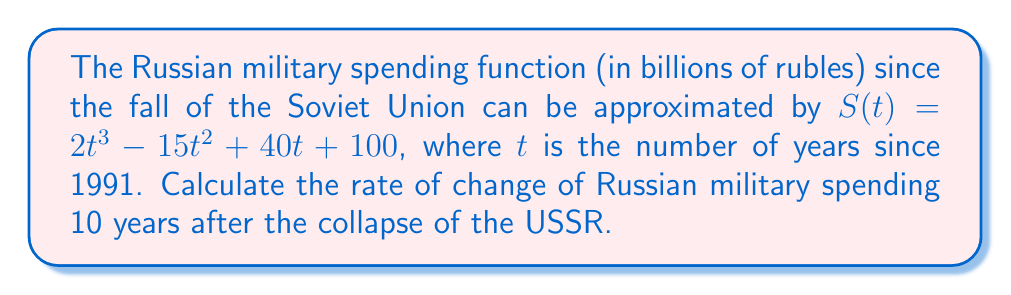Solve this math problem. To find the rate of change of Russian military spending, we need to calculate the derivative of the given function and evaluate it at $t = 10$.

Step 1: Calculate the derivative of $S(t)$.
$$S'(t) = \frac{d}{dt}(2t^3 - 15t^2 + 40t + 100)$$
$$S'(t) = 6t^2 - 30t + 40$$

Step 2: Evaluate $S'(t)$ at $t = 10$.
$$S'(10) = 6(10)^2 - 30(10) + 40$$
$$S'(10) = 600 - 300 + 40$$
$$S'(10) = 340$$

The rate of change of Russian military spending 10 years after the collapse of the Soviet Union is 340 billion rubles per year. This rapid increase in military spending demonstrates Russia's attempts to reassert its global military influence, potentially at the expense of its struggling post-Soviet economy and strained relations with former Soviet republics like Armenia.
Answer: $340$ billion rubles per year 